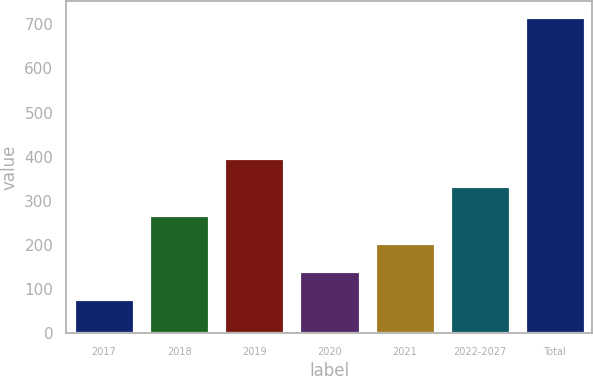<chart> <loc_0><loc_0><loc_500><loc_500><bar_chart><fcel>2017<fcel>2018<fcel>2019<fcel>2020<fcel>2021<fcel>2022-2027<fcel>Total<nl><fcel>77<fcel>269<fcel>397<fcel>141<fcel>205<fcel>333<fcel>717<nl></chart> 